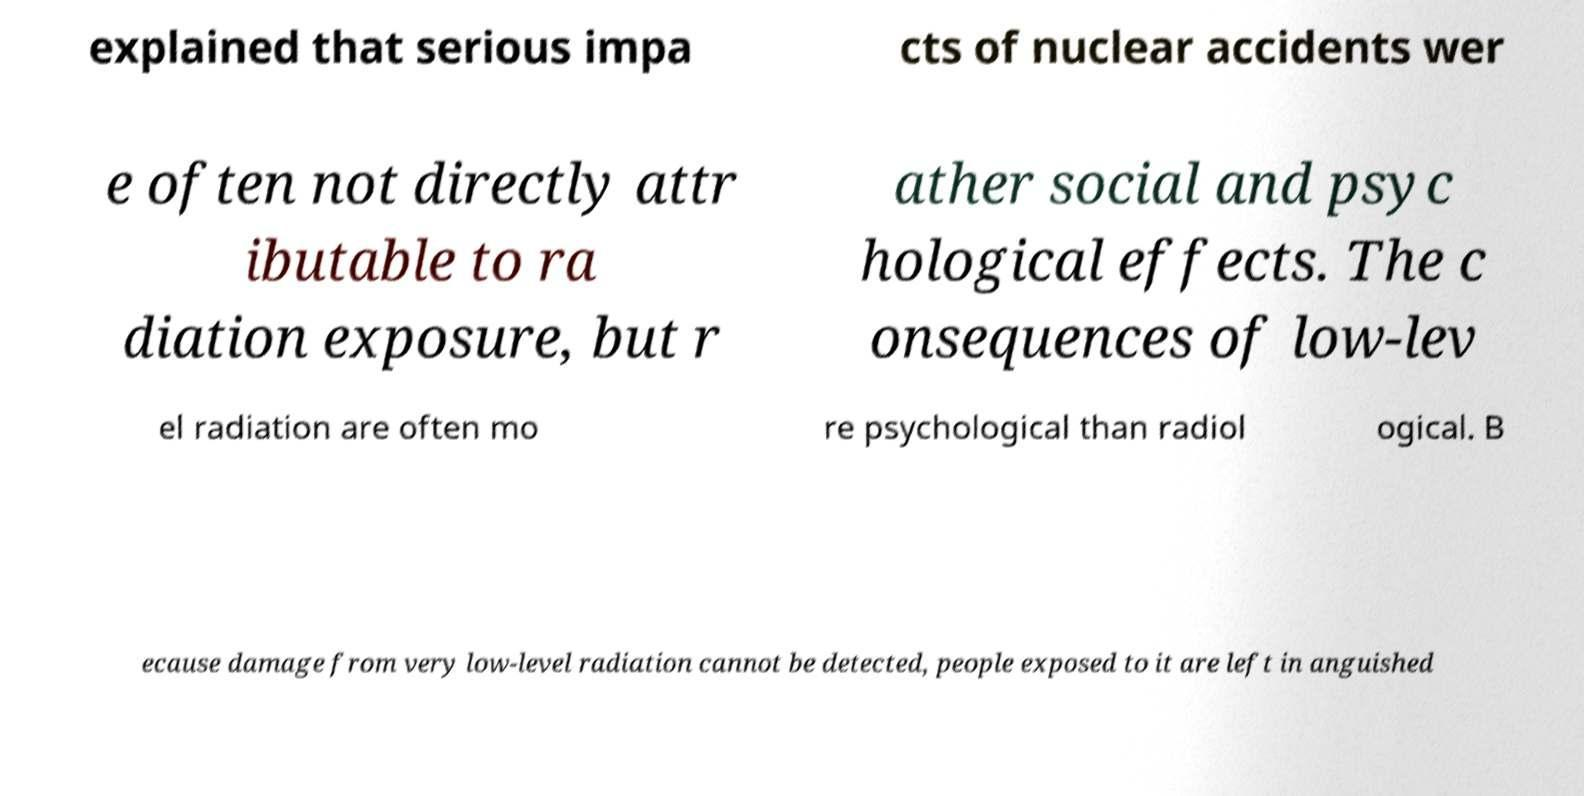There's text embedded in this image that I need extracted. Can you transcribe it verbatim? explained that serious impa cts of nuclear accidents wer e often not directly attr ibutable to ra diation exposure, but r ather social and psyc hological effects. The c onsequences of low-lev el radiation are often mo re psychological than radiol ogical. B ecause damage from very low-level radiation cannot be detected, people exposed to it are left in anguished 